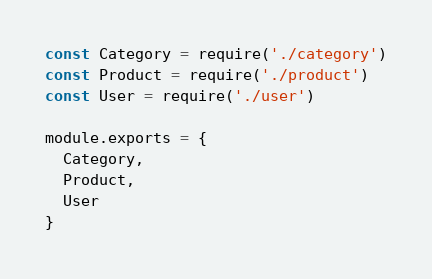Convert code to text. <code><loc_0><loc_0><loc_500><loc_500><_JavaScript_>const Category = require('./category')
const Product = require('./product')
const User = require('./user')

module.exports = {
  Category,
  Product,
  User
}
</code> 